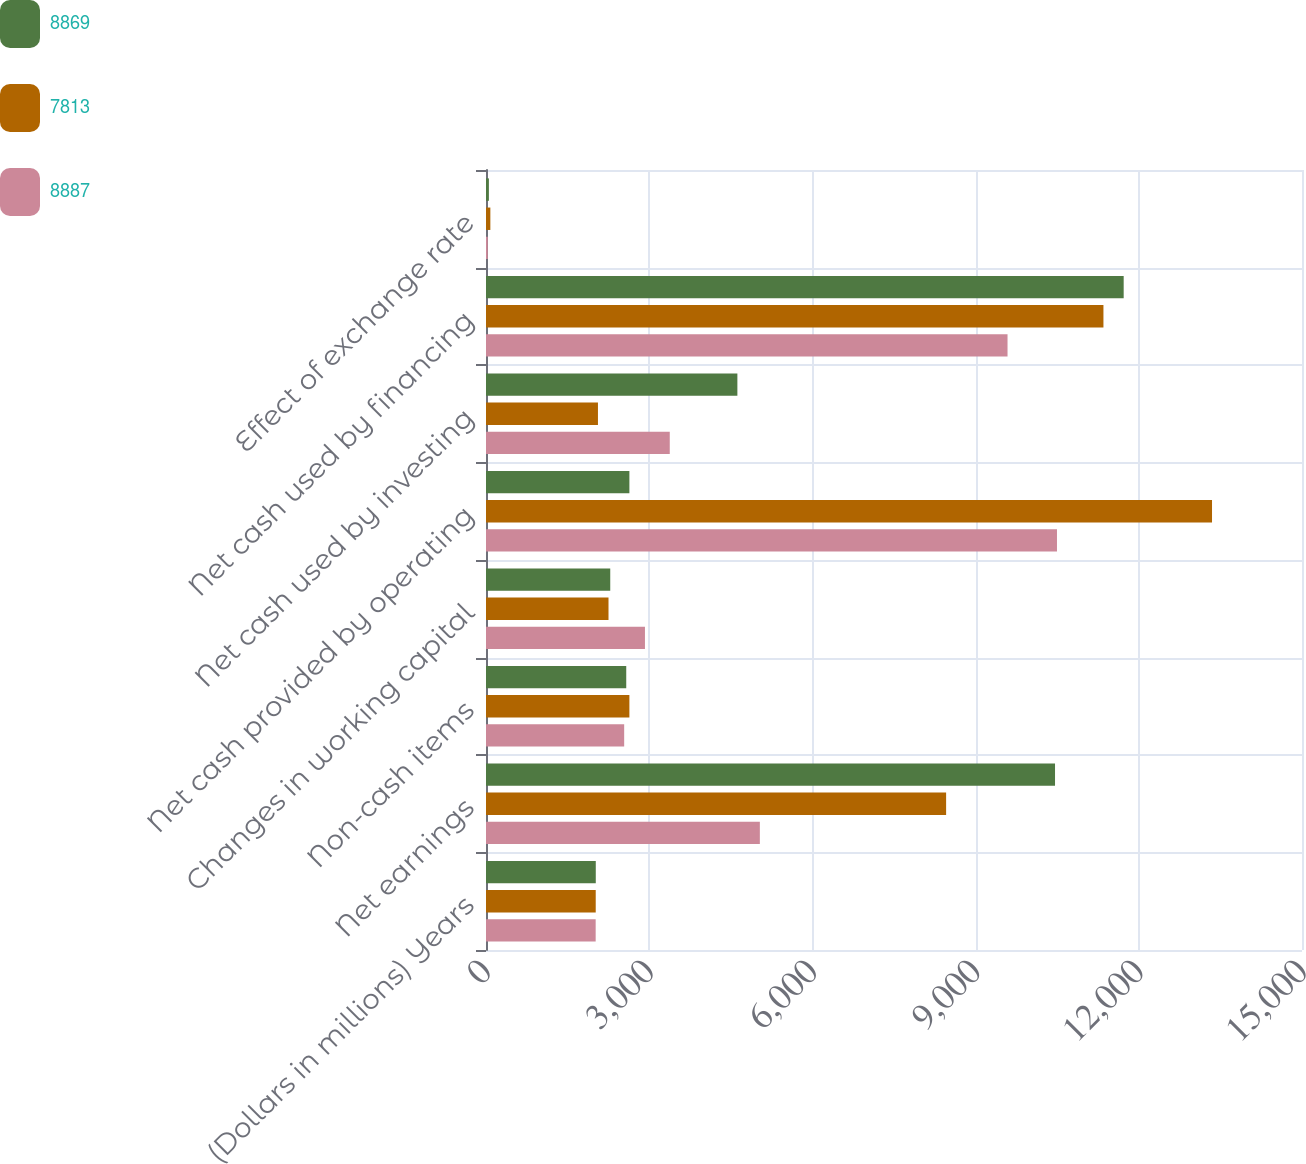<chart> <loc_0><loc_0><loc_500><loc_500><stacked_bar_chart><ecel><fcel>(Dollars in millions) Years<fcel>Net earnings<fcel>Non-cash items<fcel>Changes in working capital<fcel>Net cash provided by operating<fcel>Net cash used by investing<fcel>Net cash used by financing<fcel>Effect of exchange rate<nl><fcel>8869<fcel>2018<fcel>10460<fcel>2578<fcel>2284<fcel>2636<fcel>4621<fcel>11722<fcel>53<nl><fcel>7813<fcel>2017<fcel>8458<fcel>2636<fcel>2252<fcel>13346<fcel>2058<fcel>11350<fcel>80<nl><fcel>8887<fcel>2016<fcel>5034<fcel>2540<fcel>2922<fcel>10496<fcel>3378<fcel>9587<fcel>33<nl></chart> 